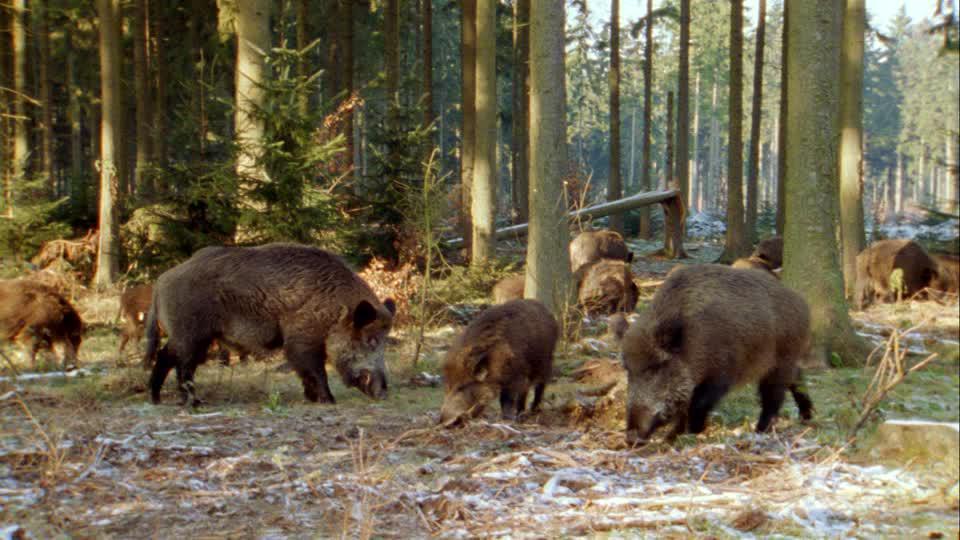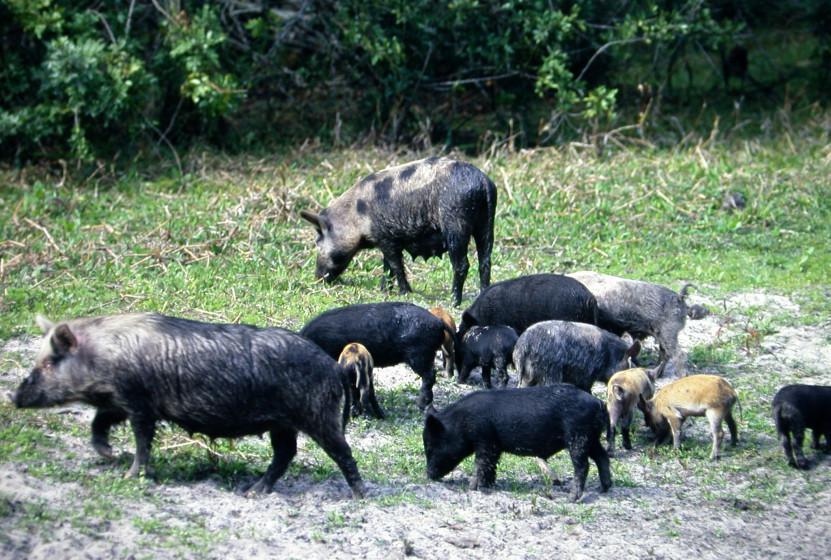The first image is the image on the left, the second image is the image on the right. Assess this claim about the two images: "An image contains no more than two warthogs, which face forward.". Correct or not? Answer yes or no. No. The first image is the image on the left, the second image is the image on the right. Examine the images to the left and right. Is the description "There are at most 5 total warthogs." accurate? Answer yes or no. No. 